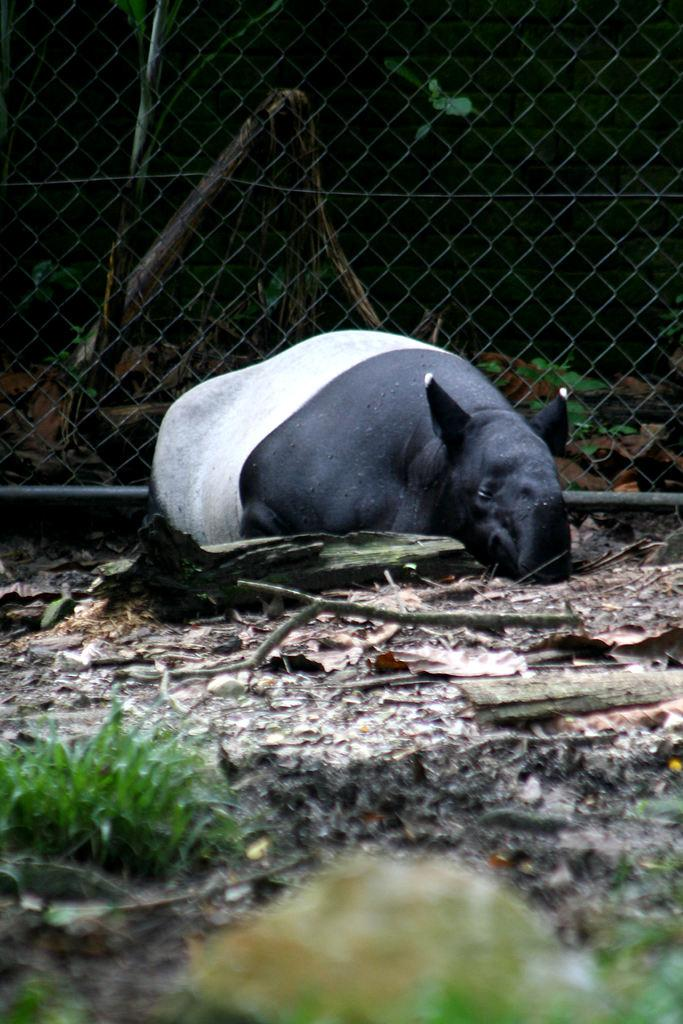What type of animal is present in the image? There is an animal in the image. What type of vegetation can be seen in the image? There is grass and plants visible in the image. What is the man-made structure present in the image? There is a wire fence in the image. What type of chicken is present in the image? There is no chicken present in the image. How many potatoes can be seen in the image? There are no potatoes present in the image. 